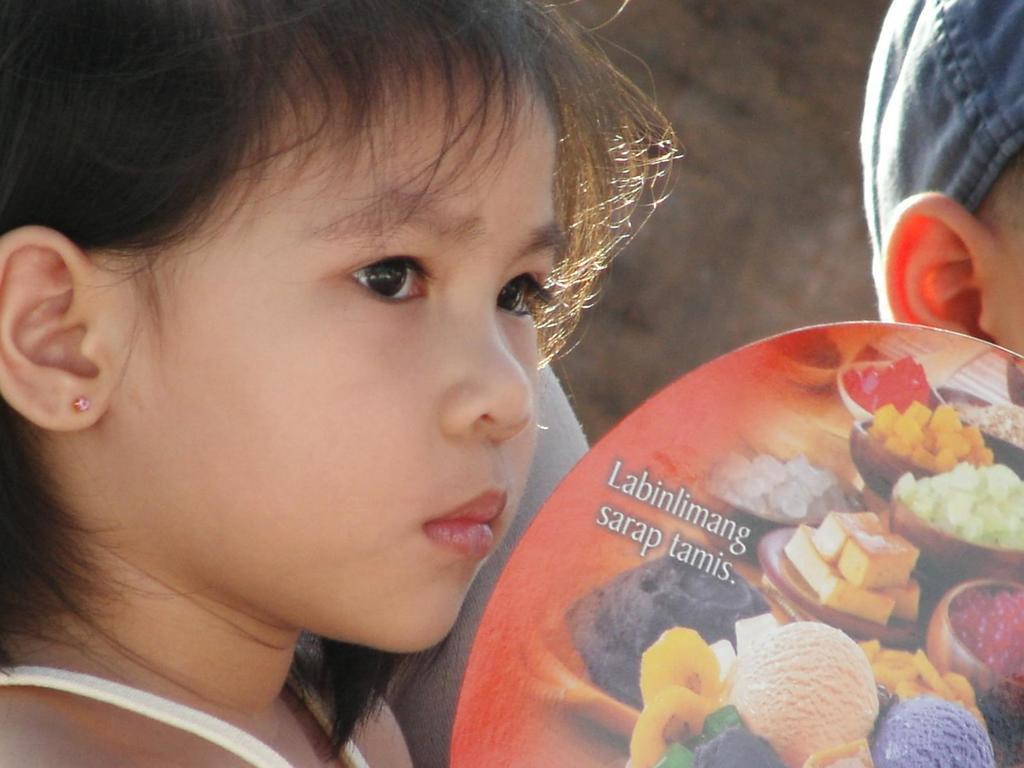In one or two sentences, can you explain what this image depicts? In this picture I can see the face of the child. 